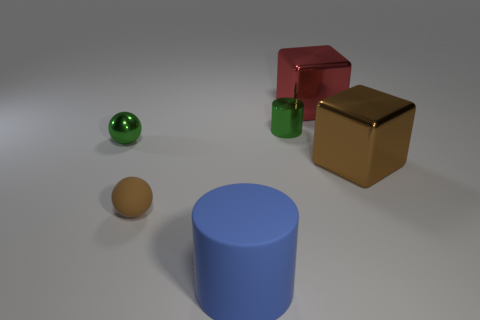There is a metal cylinder left of the large red metal thing; what size is it?
Give a very brief answer. Small. What is the size of the red block that is the same material as the large brown block?
Provide a succinct answer. Large. How many tiny matte balls are the same color as the small rubber object?
Provide a short and direct response. 0. Are there any big cyan things?
Your response must be concise. No. There is a small brown thing; is it the same shape as the big metal thing that is behind the green cylinder?
Your answer should be compact. No. What color is the metal object that is behind the green thing that is behind the green shiny object on the left side of the tiny brown rubber object?
Keep it short and to the point. Red. There is a blue cylinder; are there any matte things in front of it?
Keep it short and to the point. No. What is the size of the object that is the same color as the metal sphere?
Provide a succinct answer. Small. Is there a blue object that has the same material as the brown sphere?
Provide a short and direct response. Yes. What is the color of the tiny rubber sphere?
Give a very brief answer. Brown. 